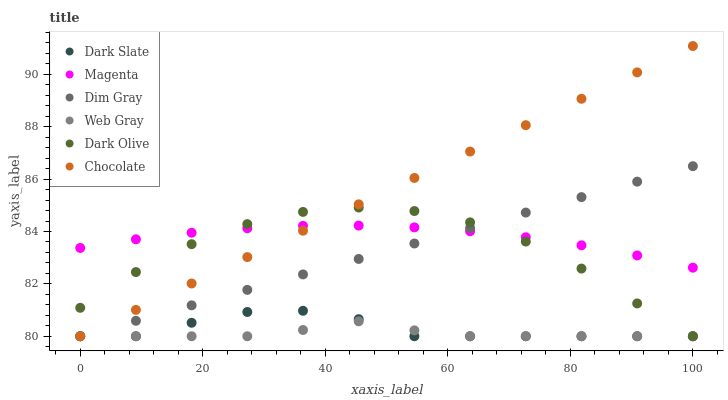Does Web Gray have the minimum area under the curve?
Answer yes or no. Yes. Does Chocolate have the maximum area under the curve?
Answer yes or no. Yes. Does Dark Olive have the minimum area under the curve?
Answer yes or no. No. Does Dark Olive have the maximum area under the curve?
Answer yes or no. No. Is Chocolate the smoothest?
Answer yes or no. Yes. Is Dark Olive the roughest?
Answer yes or no. Yes. Is Dark Olive the smoothest?
Answer yes or no. No. Is Chocolate the roughest?
Answer yes or no. No. Does Dim Gray have the lowest value?
Answer yes or no. Yes. Does Magenta have the lowest value?
Answer yes or no. No. Does Chocolate have the highest value?
Answer yes or no. Yes. Does Dark Olive have the highest value?
Answer yes or no. No. Is Web Gray less than Magenta?
Answer yes or no. Yes. Is Magenta greater than Dark Slate?
Answer yes or no. Yes. Does Chocolate intersect Dark Slate?
Answer yes or no. Yes. Is Chocolate less than Dark Slate?
Answer yes or no. No. Is Chocolate greater than Dark Slate?
Answer yes or no. No. Does Web Gray intersect Magenta?
Answer yes or no. No. 